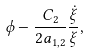<formula> <loc_0><loc_0><loc_500><loc_500>\phi - \frac { C _ { 2 } } { 2 a _ { 1 , 2 } } \frac { \dot { \xi } } { \xi } ,</formula> 